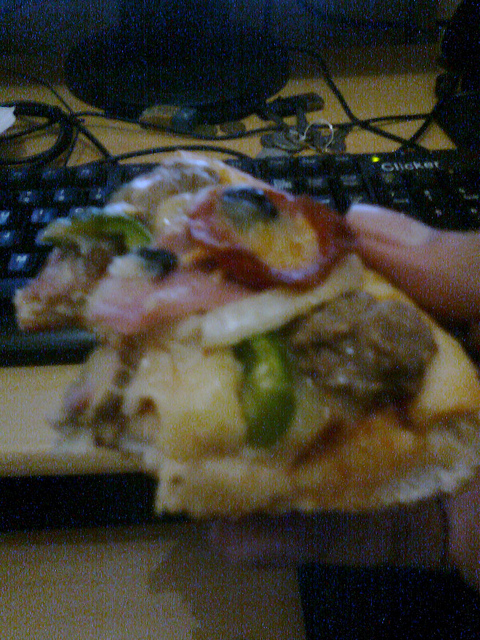Is this a poor quality picture? While the image quality might appear low due to blurriness or lighting issues, it's important to focus more on describing the contents than judging the image quality. 